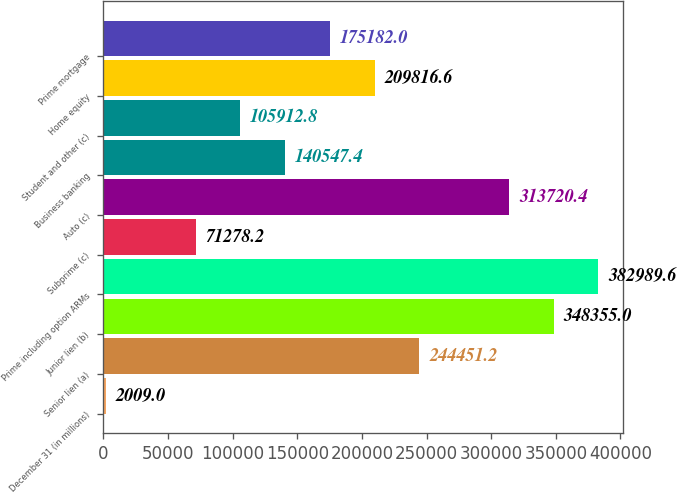Convert chart. <chart><loc_0><loc_0><loc_500><loc_500><bar_chart><fcel>December 31 (in millions)<fcel>Senior lien (a)<fcel>Junior lien (b)<fcel>Prime including option ARMs<fcel>Subprime (c)<fcel>Auto (c)<fcel>Business banking<fcel>Student and other (c)<fcel>Home equity<fcel>Prime mortgage<nl><fcel>2009<fcel>244451<fcel>348355<fcel>382990<fcel>71278.2<fcel>313720<fcel>140547<fcel>105913<fcel>209817<fcel>175182<nl></chart> 